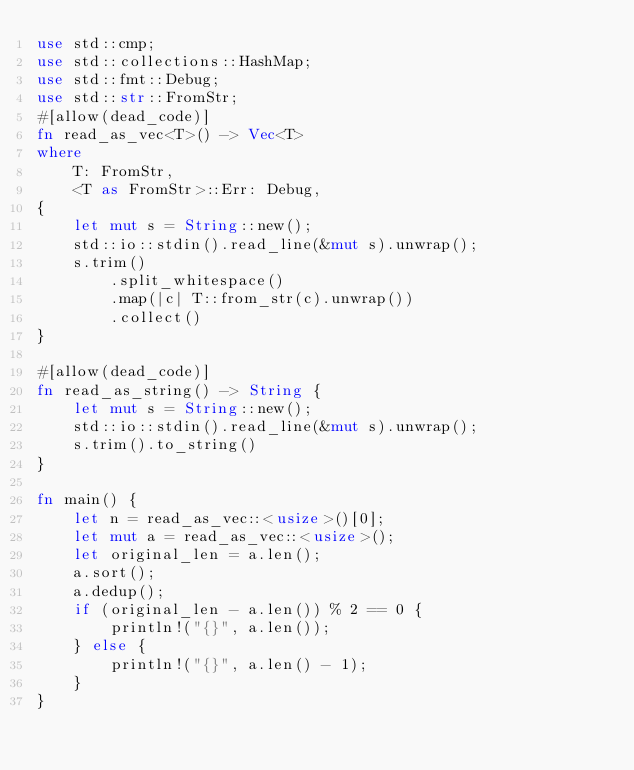<code> <loc_0><loc_0><loc_500><loc_500><_Rust_>use std::cmp;
use std::collections::HashMap;
use std::fmt::Debug;
use std::str::FromStr;
#[allow(dead_code)]
fn read_as_vec<T>() -> Vec<T>
where
    T: FromStr,
    <T as FromStr>::Err: Debug,
{
    let mut s = String::new();
    std::io::stdin().read_line(&mut s).unwrap();
    s.trim()
        .split_whitespace()
        .map(|c| T::from_str(c).unwrap())
        .collect()
}

#[allow(dead_code)]
fn read_as_string() -> String {
    let mut s = String::new();
    std::io::stdin().read_line(&mut s).unwrap();
    s.trim().to_string()
}

fn main() {
    let n = read_as_vec::<usize>()[0];
    let mut a = read_as_vec::<usize>();
    let original_len = a.len();
    a.sort();
    a.dedup();
    if (original_len - a.len()) % 2 == 0 {
        println!("{}", a.len());
    } else {
        println!("{}", a.len() - 1);
    }
}
</code> 